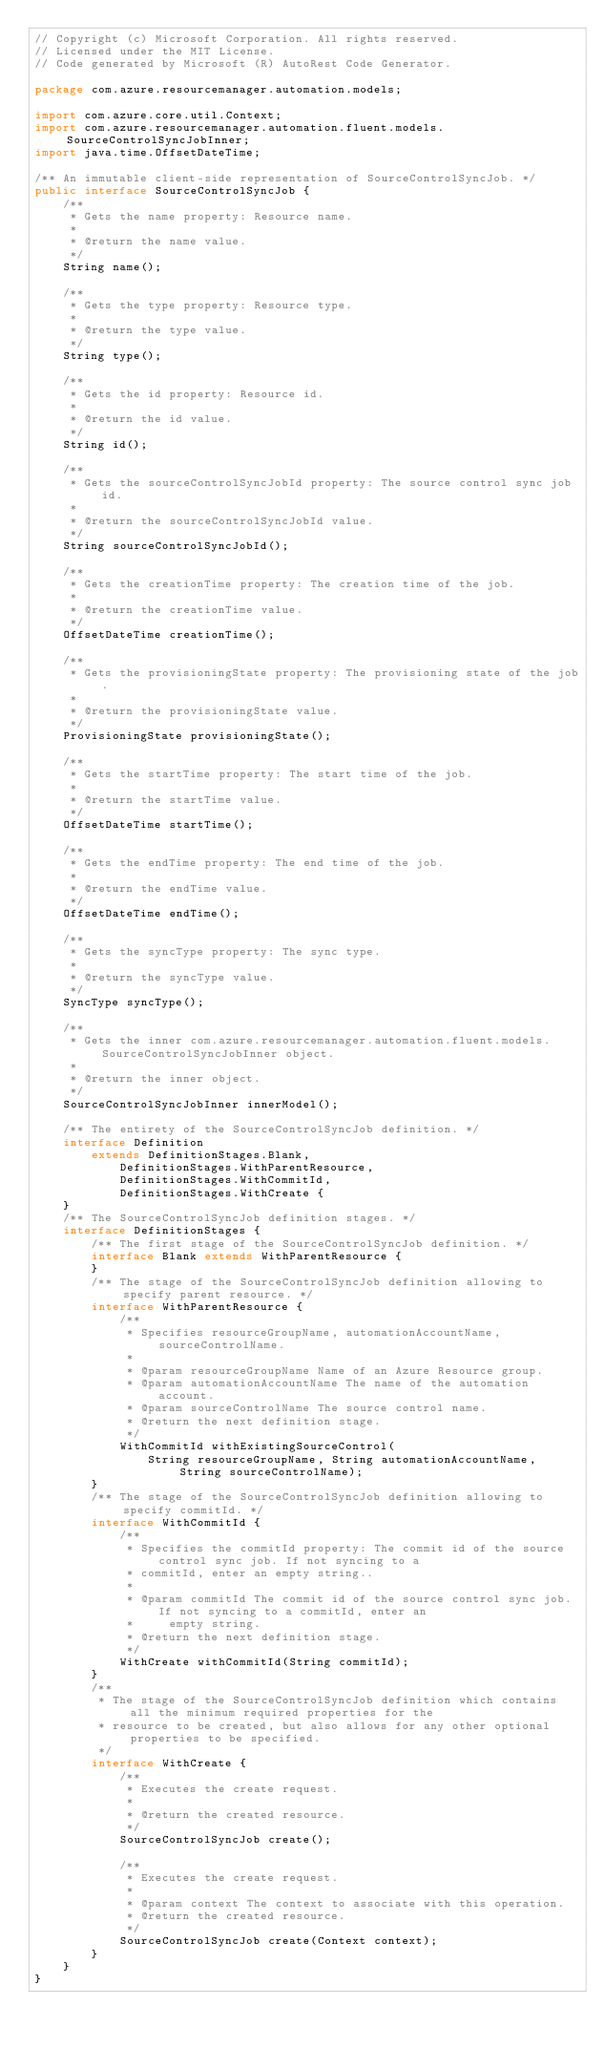<code> <loc_0><loc_0><loc_500><loc_500><_Java_>// Copyright (c) Microsoft Corporation. All rights reserved.
// Licensed under the MIT License.
// Code generated by Microsoft (R) AutoRest Code Generator.

package com.azure.resourcemanager.automation.models;

import com.azure.core.util.Context;
import com.azure.resourcemanager.automation.fluent.models.SourceControlSyncJobInner;
import java.time.OffsetDateTime;

/** An immutable client-side representation of SourceControlSyncJob. */
public interface SourceControlSyncJob {
    /**
     * Gets the name property: Resource name.
     *
     * @return the name value.
     */
    String name();

    /**
     * Gets the type property: Resource type.
     *
     * @return the type value.
     */
    String type();

    /**
     * Gets the id property: Resource id.
     *
     * @return the id value.
     */
    String id();

    /**
     * Gets the sourceControlSyncJobId property: The source control sync job id.
     *
     * @return the sourceControlSyncJobId value.
     */
    String sourceControlSyncJobId();

    /**
     * Gets the creationTime property: The creation time of the job.
     *
     * @return the creationTime value.
     */
    OffsetDateTime creationTime();

    /**
     * Gets the provisioningState property: The provisioning state of the job.
     *
     * @return the provisioningState value.
     */
    ProvisioningState provisioningState();

    /**
     * Gets the startTime property: The start time of the job.
     *
     * @return the startTime value.
     */
    OffsetDateTime startTime();

    /**
     * Gets the endTime property: The end time of the job.
     *
     * @return the endTime value.
     */
    OffsetDateTime endTime();

    /**
     * Gets the syncType property: The sync type.
     *
     * @return the syncType value.
     */
    SyncType syncType();

    /**
     * Gets the inner com.azure.resourcemanager.automation.fluent.models.SourceControlSyncJobInner object.
     *
     * @return the inner object.
     */
    SourceControlSyncJobInner innerModel();

    /** The entirety of the SourceControlSyncJob definition. */
    interface Definition
        extends DefinitionStages.Blank,
            DefinitionStages.WithParentResource,
            DefinitionStages.WithCommitId,
            DefinitionStages.WithCreate {
    }
    /** The SourceControlSyncJob definition stages. */
    interface DefinitionStages {
        /** The first stage of the SourceControlSyncJob definition. */
        interface Blank extends WithParentResource {
        }
        /** The stage of the SourceControlSyncJob definition allowing to specify parent resource. */
        interface WithParentResource {
            /**
             * Specifies resourceGroupName, automationAccountName, sourceControlName.
             *
             * @param resourceGroupName Name of an Azure Resource group.
             * @param automationAccountName The name of the automation account.
             * @param sourceControlName The source control name.
             * @return the next definition stage.
             */
            WithCommitId withExistingSourceControl(
                String resourceGroupName, String automationAccountName, String sourceControlName);
        }
        /** The stage of the SourceControlSyncJob definition allowing to specify commitId. */
        interface WithCommitId {
            /**
             * Specifies the commitId property: The commit id of the source control sync job. If not syncing to a
             * commitId, enter an empty string..
             *
             * @param commitId The commit id of the source control sync job. If not syncing to a commitId, enter an
             *     empty string.
             * @return the next definition stage.
             */
            WithCreate withCommitId(String commitId);
        }
        /**
         * The stage of the SourceControlSyncJob definition which contains all the minimum required properties for the
         * resource to be created, but also allows for any other optional properties to be specified.
         */
        interface WithCreate {
            /**
             * Executes the create request.
             *
             * @return the created resource.
             */
            SourceControlSyncJob create();

            /**
             * Executes the create request.
             *
             * @param context The context to associate with this operation.
             * @return the created resource.
             */
            SourceControlSyncJob create(Context context);
        }
    }
}
</code> 